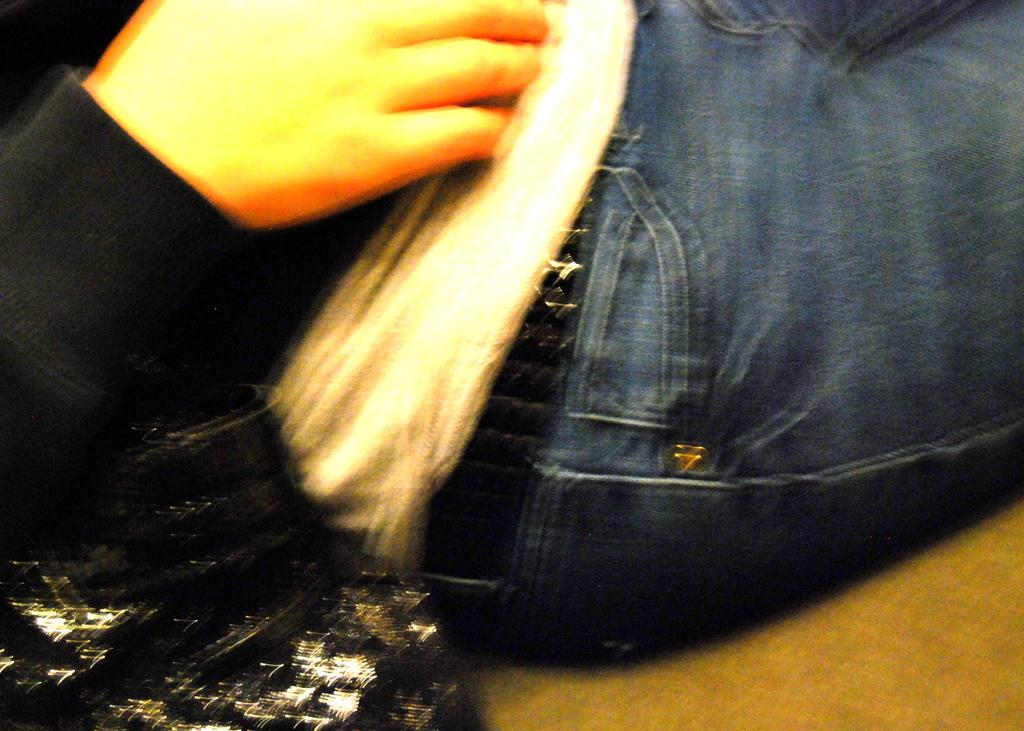Who or what is in the image? There is a person in the image. What is the person wearing? The person is wearing clothes and a belt. What is the person doing in the image? The person is sitting on a surface. What else can be seen in the image? There is a bag on the left side bottom of the image. What type of oatmeal is the person eating in the image? There is no oatmeal present in the image, and the person is not eating anything. 